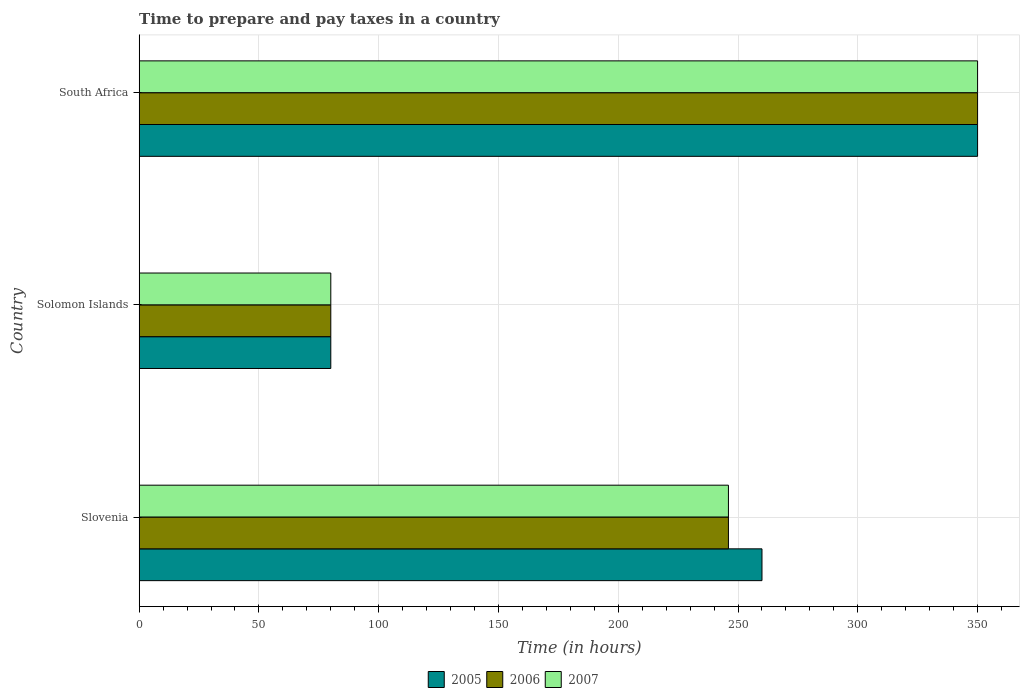How many groups of bars are there?
Offer a very short reply. 3. Are the number of bars on each tick of the Y-axis equal?
Your answer should be compact. Yes. How many bars are there on the 1st tick from the top?
Keep it short and to the point. 3. What is the label of the 2nd group of bars from the top?
Offer a terse response. Solomon Islands. In how many cases, is the number of bars for a given country not equal to the number of legend labels?
Offer a terse response. 0. What is the number of hours required to prepare and pay taxes in 2005 in South Africa?
Your answer should be very brief. 350. Across all countries, what is the maximum number of hours required to prepare and pay taxes in 2005?
Make the answer very short. 350. Across all countries, what is the minimum number of hours required to prepare and pay taxes in 2007?
Your answer should be very brief. 80. In which country was the number of hours required to prepare and pay taxes in 2007 maximum?
Your answer should be very brief. South Africa. In which country was the number of hours required to prepare and pay taxes in 2006 minimum?
Your response must be concise. Solomon Islands. What is the total number of hours required to prepare and pay taxes in 2005 in the graph?
Make the answer very short. 690. What is the difference between the number of hours required to prepare and pay taxes in 2007 in Slovenia and that in Solomon Islands?
Offer a terse response. 166. What is the difference between the number of hours required to prepare and pay taxes in 2007 in Solomon Islands and the number of hours required to prepare and pay taxes in 2006 in South Africa?
Keep it short and to the point. -270. What is the average number of hours required to prepare and pay taxes in 2006 per country?
Your answer should be very brief. 225.33. What is the difference between the number of hours required to prepare and pay taxes in 2006 and number of hours required to prepare and pay taxes in 2007 in South Africa?
Your response must be concise. 0. In how many countries, is the number of hours required to prepare and pay taxes in 2006 greater than 110 hours?
Keep it short and to the point. 2. What is the ratio of the number of hours required to prepare and pay taxes in 2005 in Solomon Islands to that in South Africa?
Your answer should be very brief. 0.23. Is the difference between the number of hours required to prepare and pay taxes in 2006 in Slovenia and South Africa greater than the difference between the number of hours required to prepare and pay taxes in 2007 in Slovenia and South Africa?
Your response must be concise. No. What is the difference between the highest and the second highest number of hours required to prepare and pay taxes in 2007?
Offer a very short reply. 104. What is the difference between the highest and the lowest number of hours required to prepare and pay taxes in 2005?
Make the answer very short. 270. In how many countries, is the number of hours required to prepare and pay taxes in 2006 greater than the average number of hours required to prepare and pay taxes in 2006 taken over all countries?
Give a very brief answer. 2. What does the 3rd bar from the top in Slovenia represents?
Offer a very short reply. 2005. Are all the bars in the graph horizontal?
Make the answer very short. Yes. Does the graph contain any zero values?
Provide a short and direct response. No. Where does the legend appear in the graph?
Provide a succinct answer. Bottom center. How many legend labels are there?
Make the answer very short. 3. What is the title of the graph?
Provide a succinct answer. Time to prepare and pay taxes in a country. Does "1977" appear as one of the legend labels in the graph?
Give a very brief answer. No. What is the label or title of the X-axis?
Your answer should be compact. Time (in hours). What is the label or title of the Y-axis?
Ensure brevity in your answer.  Country. What is the Time (in hours) of 2005 in Slovenia?
Offer a very short reply. 260. What is the Time (in hours) in 2006 in Slovenia?
Keep it short and to the point. 246. What is the Time (in hours) of 2007 in Slovenia?
Offer a terse response. 246. What is the Time (in hours) of 2005 in Solomon Islands?
Give a very brief answer. 80. What is the Time (in hours) in 2007 in Solomon Islands?
Provide a succinct answer. 80. What is the Time (in hours) of 2005 in South Africa?
Make the answer very short. 350. What is the Time (in hours) of 2006 in South Africa?
Offer a very short reply. 350. What is the Time (in hours) of 2007 in South Africa?
Provide a short and direct response. 350. Across all countries, what is the maximum Time (in hours) of 2005?
Provide a short and direct response. 350. Across all countries, what is the maximum Time (in hours) of 2006?
Offer a terse response. 350. Across all countries, what is the maximum Time (in hours) of 2007?
Provide a short and direct response. 350. Across all countries, what is the minimum Time (in hours) in 2006?
Provide a short and direct response. 80. Across all countries, what is the minimum Time (in hours) in 2007?
Keep it short and to the point. 80. What is the total Time (in hours) in 2005 in the graph?
Offer a terse response. 690. What is the total Time (in hours) of 2006 in the graph?
Your answer should be compact. 676. What is the total Time (in hours) in 2007 in the graph?
Keep it short and to the point. 676. What is the difference between the Time (in hours) of 2005 in Slovenia and that in Solomon Islands?
Your answer should be compact. 180. What is the difference between the Time (in hours) of 2006 in Slovenia and that in Solomon Islands?
Provide a short and direct response. 166. What is the difference between the Time (in hours) of 2007 in Slovenia and that in Solomon Islands?
Offer a terse response. 166. What is the difference between the Time (in hours) in 2005 in Slovenia and that in South Africa?
Make the answer very short. -90. What is the difference between the Time (in hours) in 2006 in Slovenia and that in South Africa?
Make the answer very short. -104. What is the difference between the Time (in hours) of 2007 in Slovenia and that in South Africa?
Offer a very short reply. -104. What is the difference between the Time (in hours) in 2005 in Solomon Islands and that in South Africa?
Offer a very short reply. -270. What is the difference between the Time (in hours) of 2006 in Solomon Islands and that in South Africa?
Make the answer very short. -270. What is the difference between the Time (in hours) in 2007 in Solomon Islands and that in South Africa?
Offer a terse response. -270. What is the difference between the Time (in hours) of 2005 in Slovenia and the Time (in hours) of 2006 in Solomon Islands?
Make the answer very short. 180. What is the difference between the Time (in hours) in 2005 in Slovenia and the Time (in hours) in 2007 in Solomon Islands?
Your answer should be compact. 180. What is the difference between the Time (in hours) of 2006 in Slovenia and the Time (in hours) of 2007 in Solomon Islands?
Your answer should be compact. 166. What is the difference between the Time (in hours) of 2005 in Slovenia and the Time (in hours) of 2006 in South Africa?
Keep it short and to the point. -90. What is the difference between the Time (in hours) in 2005 in Slovenia and the Time (in hours) in 2007 in South Africa?
Give a very brief answer. -90. What is the difference between the Time (in hours) in 2006 in Slovenia and the Time (in hours) in 2007 in South Africa?
Offer a terse response. -104. What is the difference between the Time (in hours) of 2005 in Solomon Islands and the Time (in hours) of 2006 in South Africa?
Offer a terse response. -270. What is the difference between the Time (in hours) of 2005 in Solomon Islands and the Time (in hours) of 2007 in South Africa?
Offer a terse response. -270. What is the difference between the Time (in hours) in 2006 in Solomon Islands and the Time (in hours) in 2007 in South Africa?
Keep it short and to the point. -270. What is the average Time (in hours) in 2005 per country?
Give a very brief answer. 230. What is the average Time (in hours) in 2006 per country?
Give a very brief answer. 225.33. What is the average Time (in hours) of 2007 per country?
Keep it short and to the point. 225.33. What is the difference between the Time (in hours) in 2005 and Time (in hours) in 2006 in Slovenia?
Provide a short and direct response. 14. What is the difference between the Time (in hours) in 2005 and Time (in hours) in 2007 in Slovenia?
Give a very brief answer. 14. What is the difference between the Time (in hours) in 2005 and Time (in hours) in 2007 in South Africa?
Provide a succinct answer. 0. What is the ratio of the Time (in hours) of 2006 in Slovenia to that in Solomon Islands?
Give a very brief answer. 3.08. What is the ratio of the Time (in hours) of 2007 in Slovenia to that in Solomon Islands?
Keep it short and to the point. 3.08. What is the ratio of the Time (in hours) of 2005 in Slovenia to that in South Africa?
Offer a very short reply. 0.74. What is the ratio of the Time (in hours) in 2006 in Slovenia to that in South Africa?
Offer a very short reply. 0.7. What is the ratio of the Time (in hours) of 2007 in Slovenia to that in South Africa?
Keep it short and to the point. 0.7. What is the ratio of the Time (in hours) in 2005 in Solomon Islands to that in South Africa?
Ensure brevity in your answer.  0.23. What is the ratio of the Time (in hours) in 2006 in Solomon Islands to that in South Africa?
Keep it short and to the point. 0.23. What is the ratio of the Time (in hours) in 2007 in Solomon Islands to that in South Africa?
Offer a terse response. 0.23. What is the difference between the highest and the second highest Time (in hours) in 2006?
Keep it short and to the point. 104. What is the difference between the highest and the second highest Time (in hours) of 2007?
Your response must be concise. 104. What is the difference between the highest and the lowest Time (in hours) in 2005?
Give a very brief answer. 270. What is the difference between the highest and the lowest Time (in hours) of 2006?
Ensure brevity in your answer.  270. What is the difference between the highest and the lowest Time (in hours) of 2007?
Provide a short and direct response. 270. 